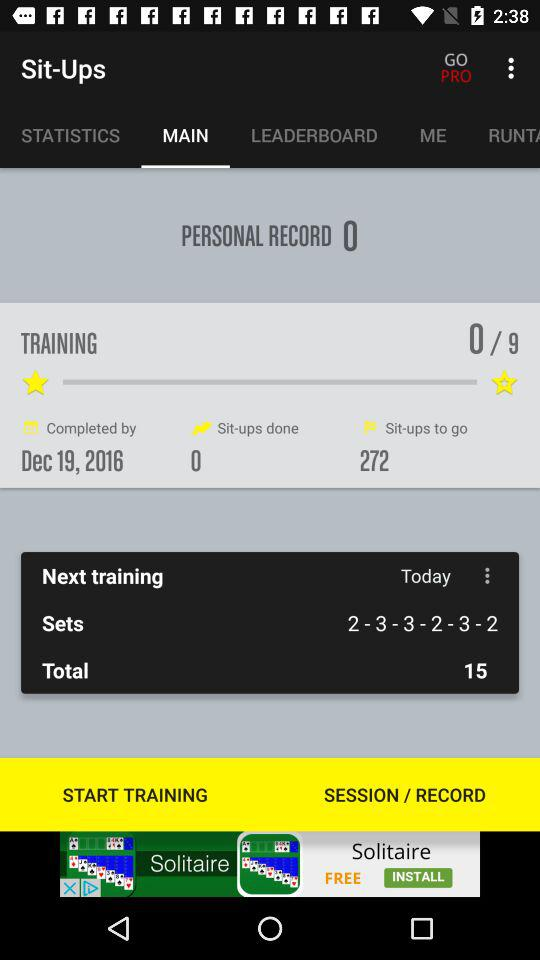Which training am I in? You are in training 0. 